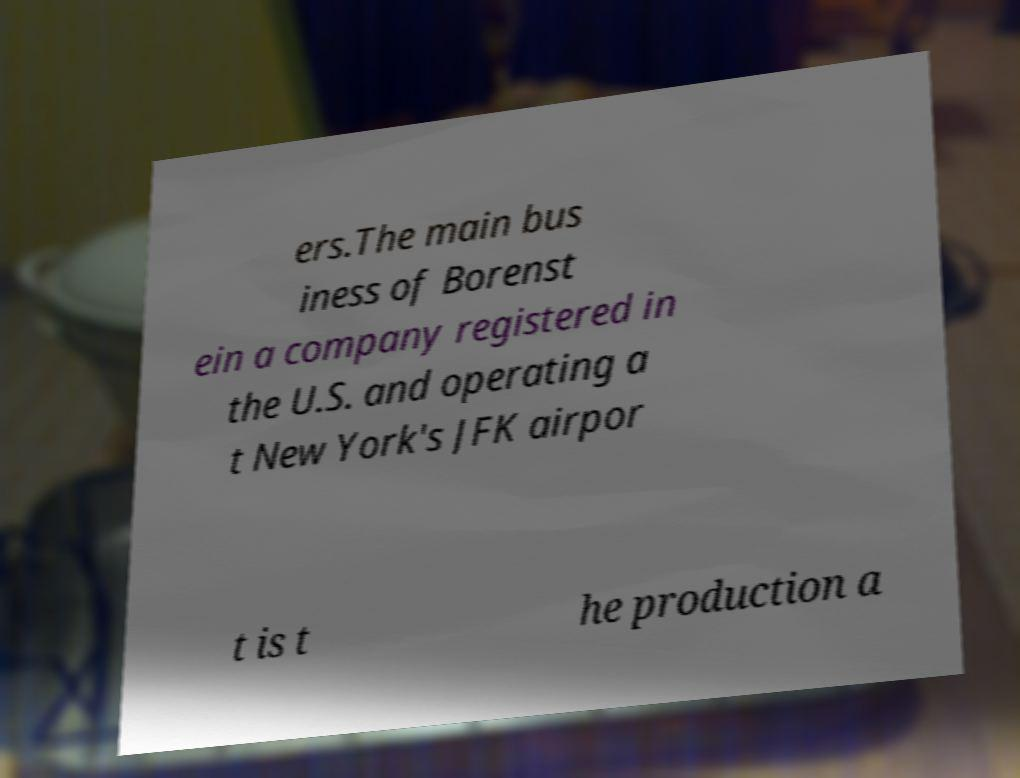Please read and relay the text visible in this image. What does it say? ers.The main bus iness of Borenst ein a company registered in the U.S. and operating a t New York's JFK airpor t is t he production a 